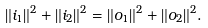<formula> <loc_0><loc_0><loc_500><loc_500>\| i _ { 1 } \| ^ { 2 } + \| i _ { 2 } \| ^ { 2 } = \| o _ { 1 } \| ^ { 2 } + \| o _ { 2 } \| ^ { 2 } .</formula> 